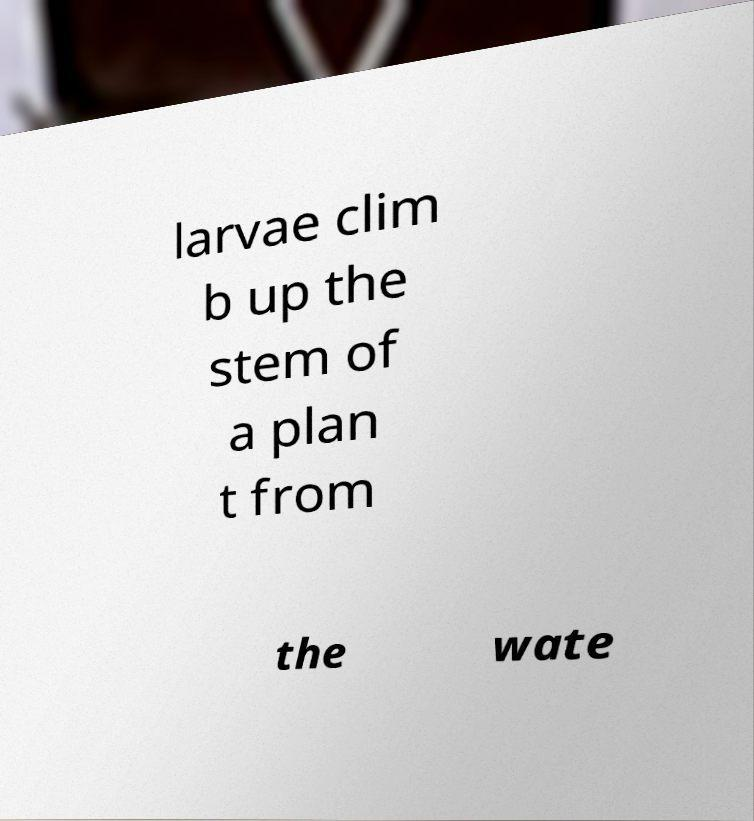Could you assist in decoding the text presented in this image and type it out clearly? larvae clim b up the stem of a plan t from the wate 